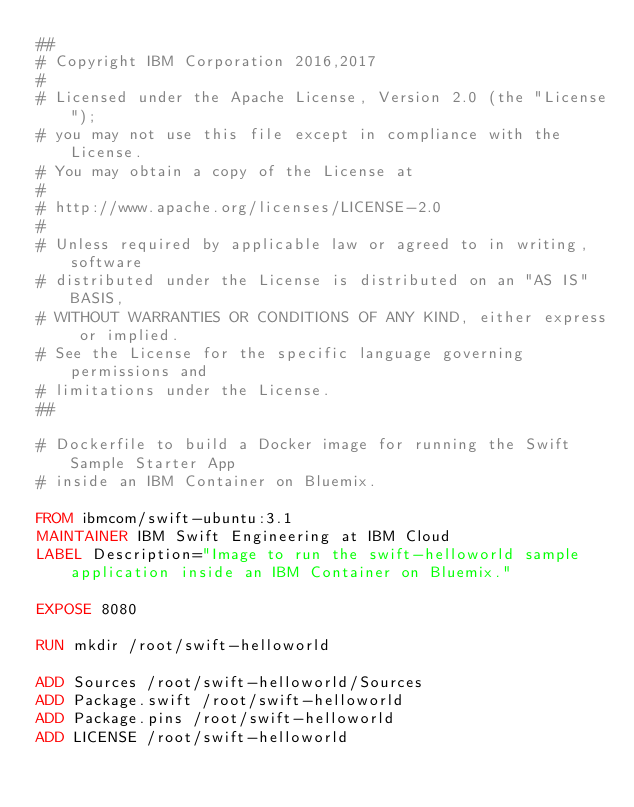<code> <loc_0><loc_0><loc_500><loc_500><_Dockerfile_>##
# Copyright IBM Corporation 2016,2017
#
# Licensed under the Apache License, Version 2.0 (the "License");
# you may not use this file except in compliance with the License.
# You may obtain a copy of the License at
#
# http://www.apache.org/licenses/LICENSE-2.0
#
# Unless required by applicable law or agreed to in writing, software
# distributed under the License is distributed on an "AS IS" BASIS,
# WITHOUT WARRANTIES OR CONDITIONS OF ANY KIND, either express or implied.
# See the License for the specific language governing permissions and
# limitations under the License.
##

# Dockerfile to build a Docker image for running the Swift Sample Starter App
# inside an IBM Container on Bluemix.

FROM ibmcom/swift-ubuntu:3.1
MAINTAINER IBM Swift Engineering at IBM Cloud
LABEL Description="Image to run the swift-helloworld sample application inside an IBM Container on Bluemix."

EXPOSE 8080

RUN mkdir /root/swift-helloworld

ADD Sources /root/swift-helloworld/Sources
ADD Package.swift /root/swift-helloworld
ADD Package.pins /root/swift-helloworld
ADD LICENSE /root/swift-helloworld</code> 